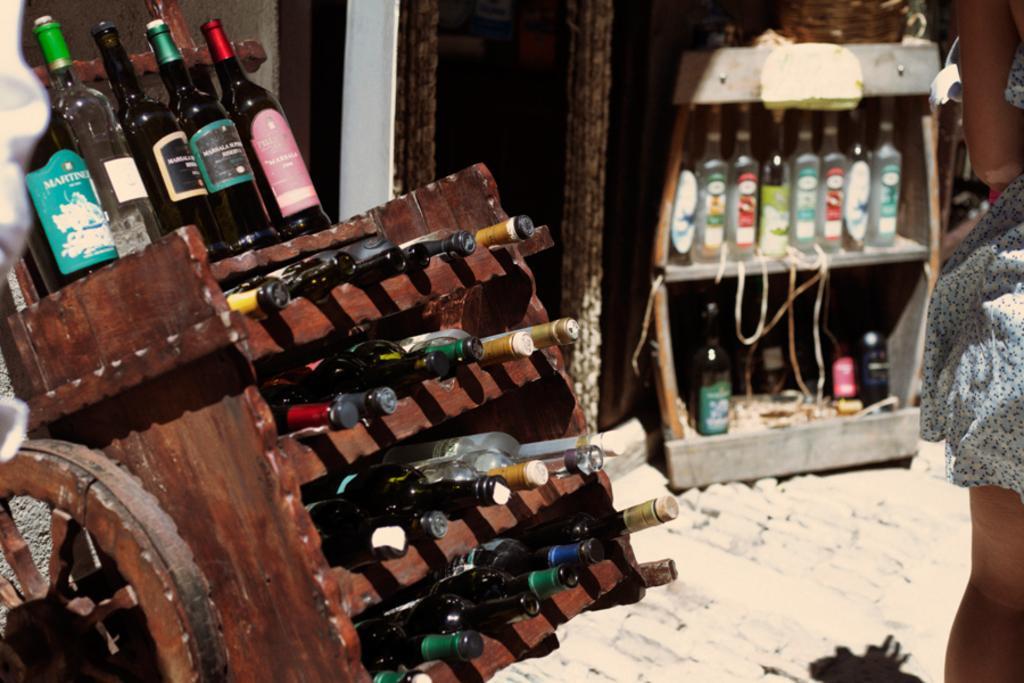Describe this image in one or two sentences. In this image, we can see some bottles in the rack. There is a moving rack on the left side of the image contains some bottles. There is a person on the right side of the image. 